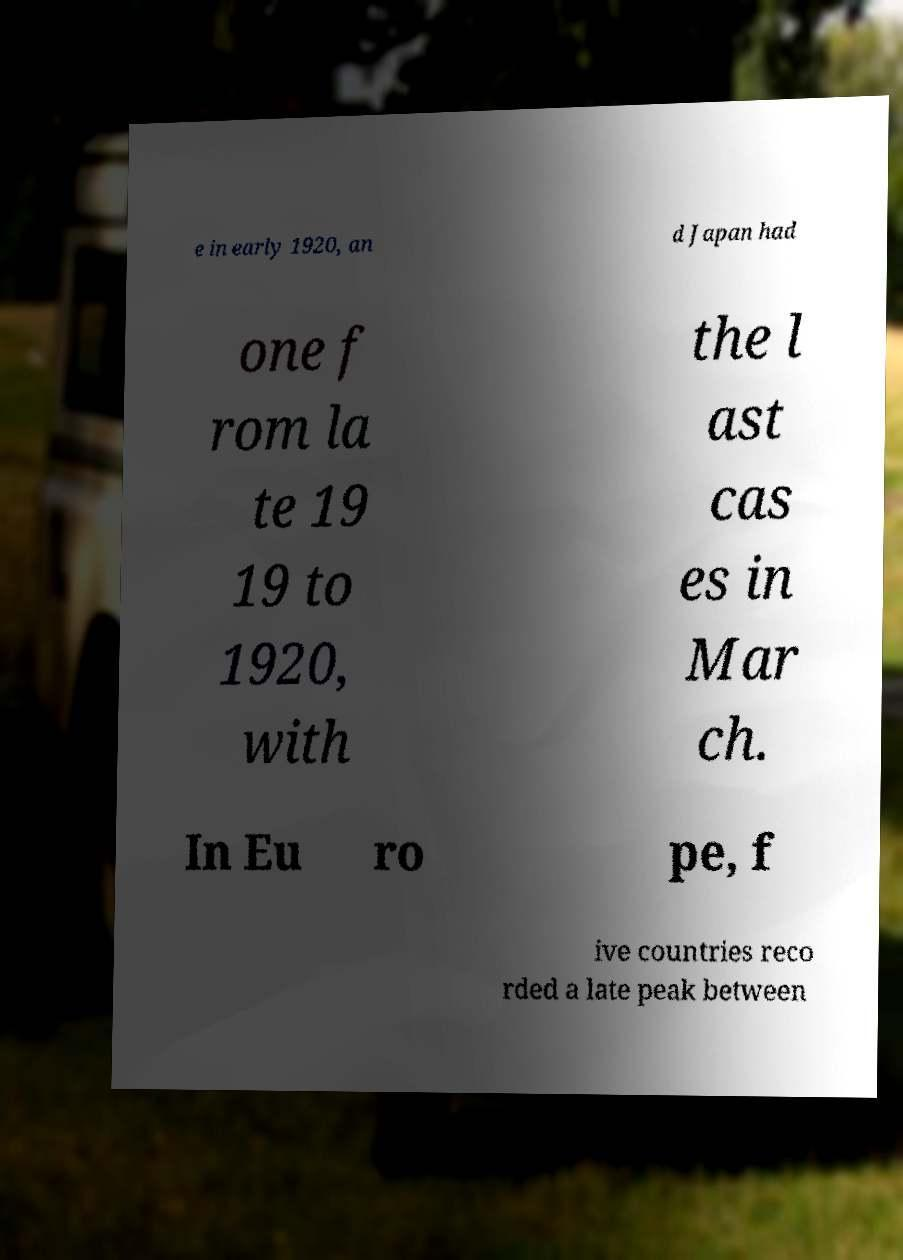What messages or text are displayed in this image? I need them in a readable, typed format. e in early 1920, an d Japan had one f rom la te 19 19 to 1920, with the l ast cas es in Mar ch. In Eu ro pe, f ive countries reco rded a late peak between 